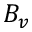<formula> <loc_0><loc_0><loc_500><loc_500>B _ { v }</formula> 